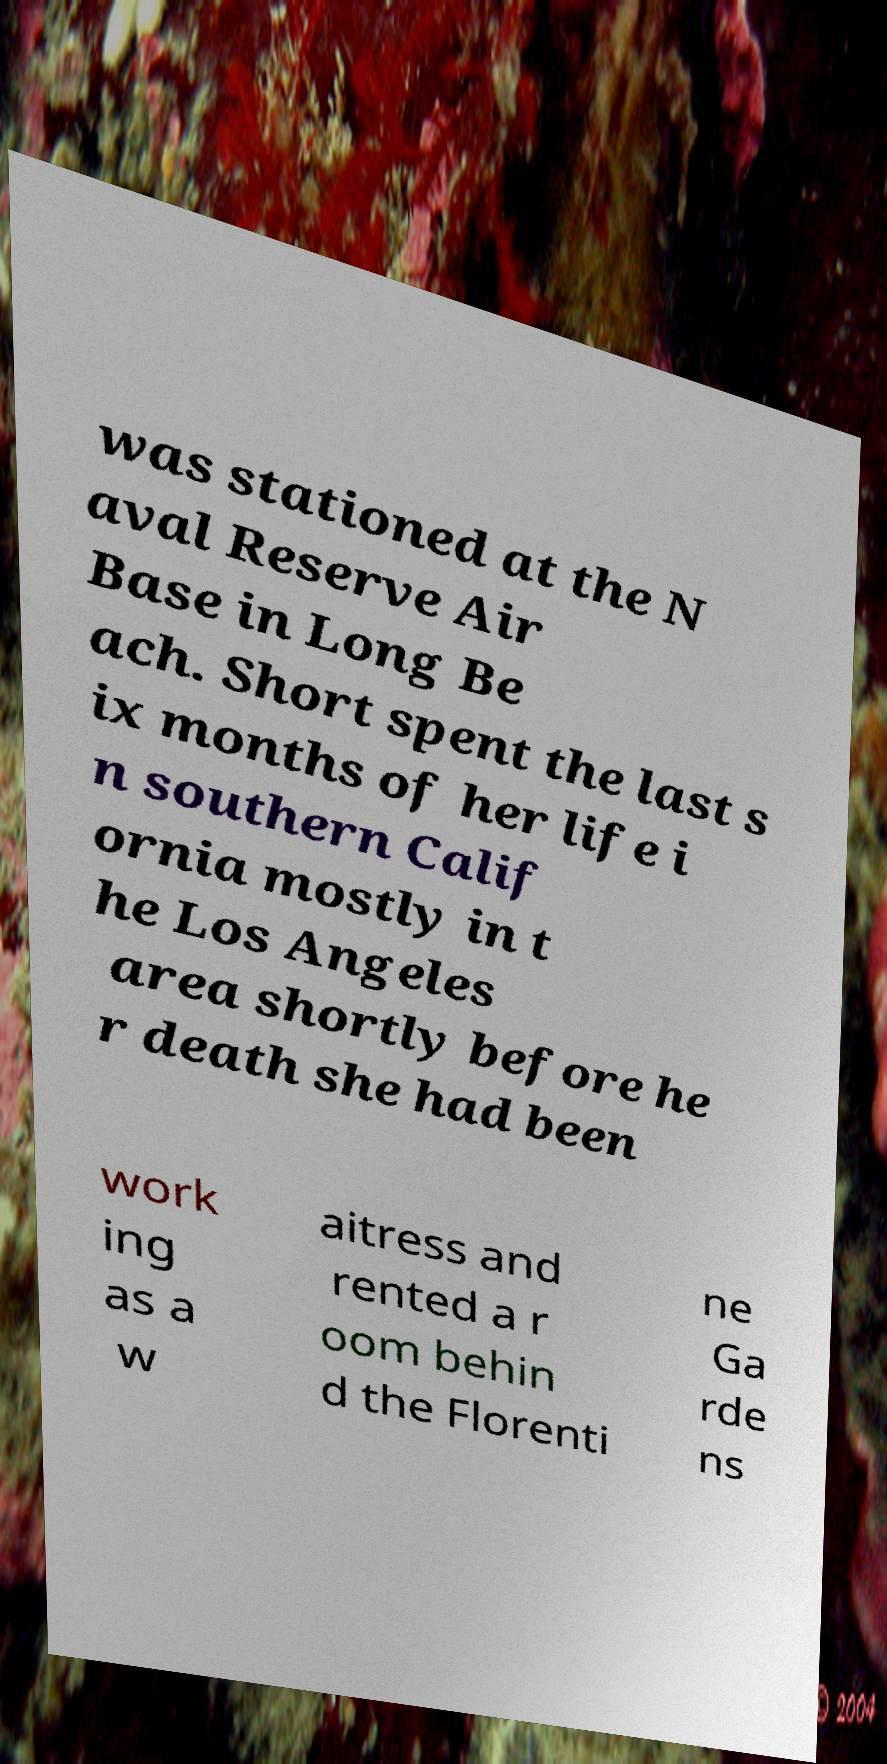Please identify and transcribe the text found in this image. was stationed at the N aval Reserve Air Base in Long Be ach. Short spent the last s ix months of her life i n southern Calif ornia mostly in t he Los Angeles area shortly before he r death she had been work ing as a w aitress and rented a r oom behin d the Florenti ne Ga rde ns 